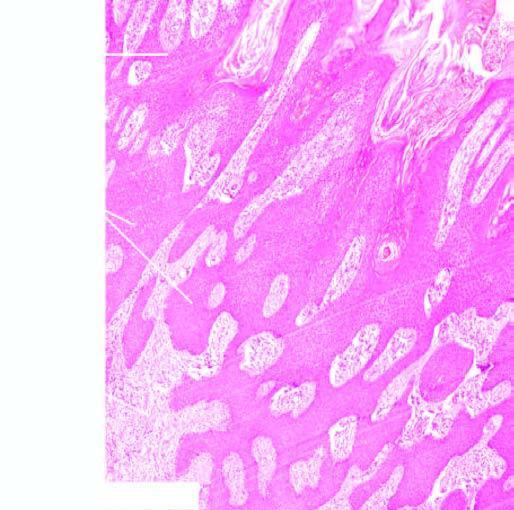what shows an increase in the number of layers of the squamous epithelium?
Answer the question using a single word or phrase. Epidermis 